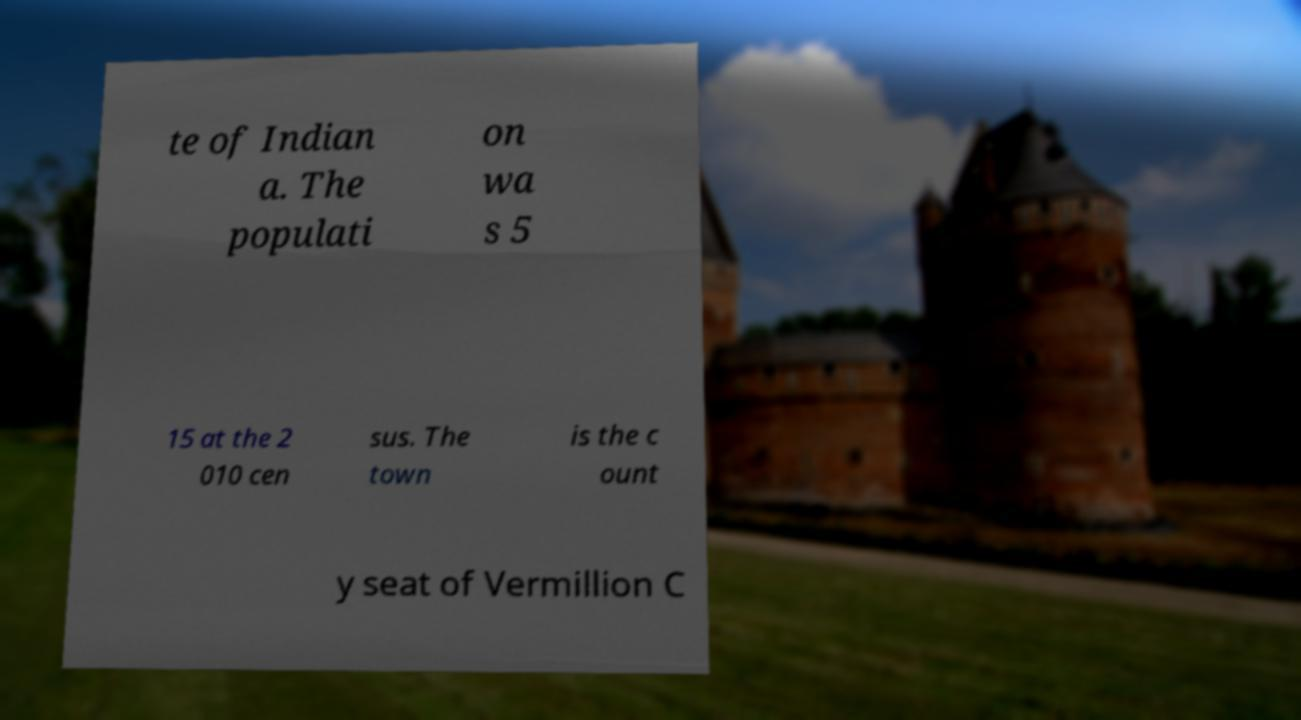Could you extract and type out the text from this image? te of Indian a. The populati on wa s 5 15 at the 2 010 cen sus. The town is the c ount y seat of Vermillion C 